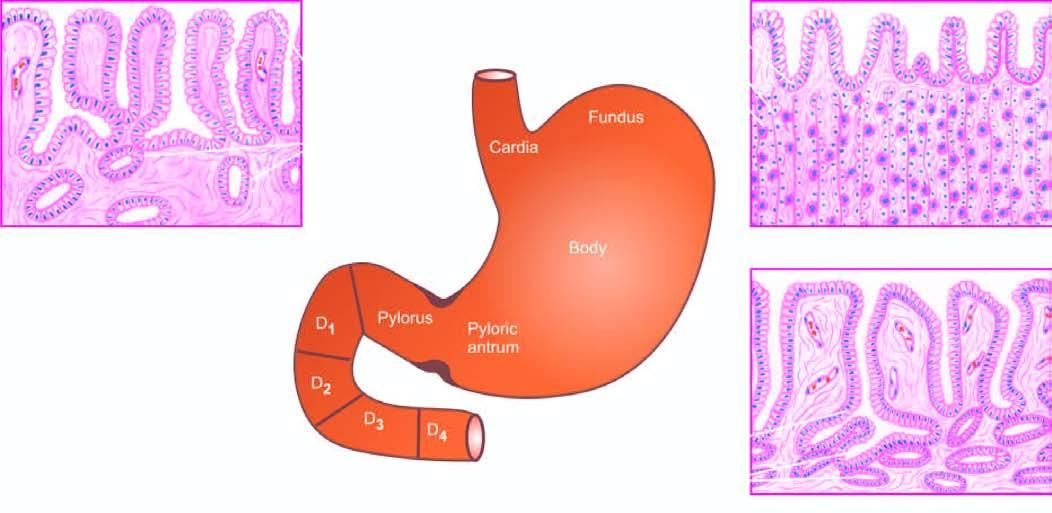what are correlated with histological appearance of gastric mucosa in different regions?
Answer the question using a single word or phrase. Natomical subdivisions of the stomach 